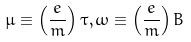<formula> <loc_0><loc_0><loc_500><loc_500>\mu \equiv \left ( \frac { e } { m } \right ) \tau , \omega \equiv \left ( \frac { e } { m } \right ) B</formula> 